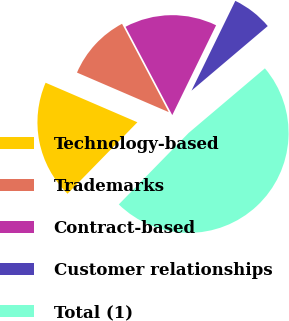Convert chart to OTSL. <chart><loc_0><loc_0><loc_500><loc_500><pie_chart><fcel>Technology-based<fcel>Trademarks<fcel>Contract-based<fcel>Customer relationships<fcel>Total (1)<nl><fcel>19.16%<fcel>10.78%<fcel>14.97%<fcel>6.59%<fcel>48.5%<nl></chart> 